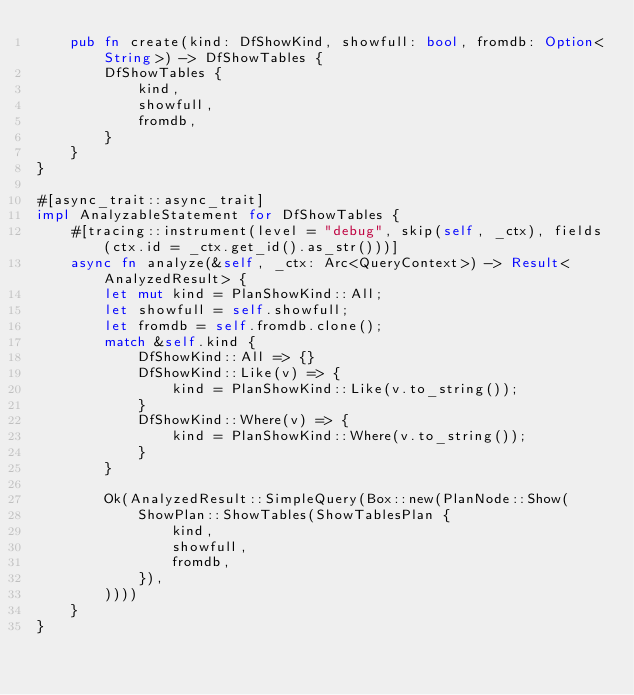Convert code to text. <code><loc_0><loc_0><loc_500><loc_500><_Rust_>    pub fn create(kind: DfShowKind, showfull: bool, fromdb: Option<String>) -> DfShowTables {
        DfShowTables {
            kind,
            showfull,
            fromdb,
        }
    }
}

#[async_trait::async_trait]
impl AnalyzableStatement for DfShowTables {
    #[tracing::instrument(level = "debug", skip(self, _ctx), fields(ctx.id = _ctx.get_id().as_str()))]
    async fn analyze(&self, _ctx: Arc<QueryContext>) -> Result<AnalyzedResult> {
        let mut kind = PlanShowKind::All;
        let showfull = self.showfull;
        let fromdb = self.fromdb.clone();
        match &self.kind {
            DfShowKind::All => {}
            DfShowKind::Like(v) => {
                kind = PlanShowKind::Like(v.to_string());
            }
            DfShowKind::Where(v) => {
                kind = PlanShowKind::Where(v.to_string());
            }
        }

        Ok(AnalyzedResult::SimpleQuery(Box::new(PlanNode::Show(
            ShowPlan::ShowTables(ShowTablesPlan {
                kind,
                showfull,
                fromdb,
            }),
        ))))
    }
}
</code> 